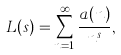<formula> <loc_0><loc_0><loc_500><loc_500>L ( s ) = \sum _ { n = 1 } ^ { \infty } \frac { a ( n ) } { n ^ { s } } ,</formula> 